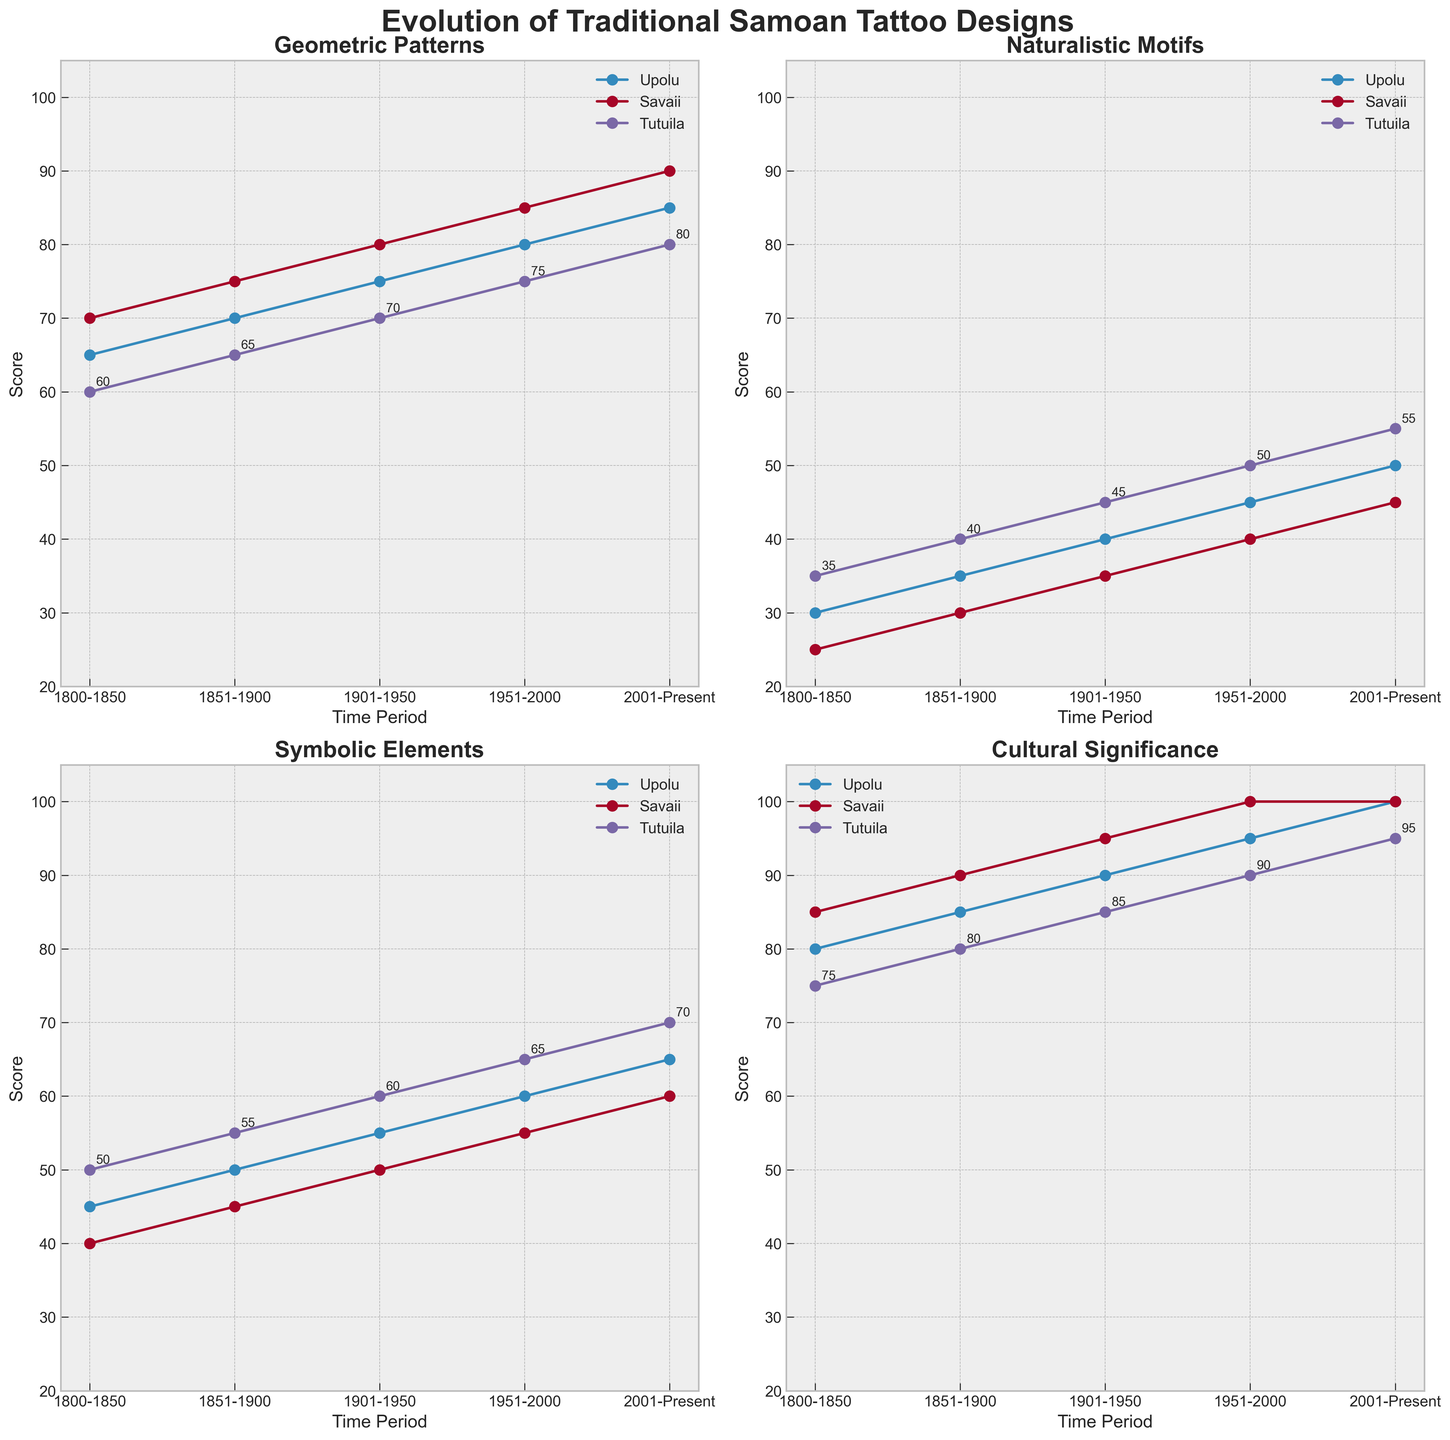Which region has the highest score for Geometric Patterns in the period 2001-Present? By looking at the "Geometric Patterns" subplot and noting the highest points for the period 2001-Present, it can be seen that Savaii has the highest score.
Answer: Savaii Which region shows the greatest increase in Cultural Significance from 1800-1850 to 2001-Present? To find this, assess the Cultural Significance subplot by subtracting the scores from 1800-1850 to 2001-Present for each region. Upolu shows an increase from 80 to 100 (20 points), Savaii from 85 to 100 (15 points), and Tutuila from 75 to 95 (20 points). Both Upolu and Tutuila have the greatest increase of 20 points.
Answer: Upolu and Tutuila What is the sum of Naturalistic Motifs scores for Upolu across all time periods? Add the Naturalistic Motifs scores for Upolu from each time period: 30 + 35 + 40 + 45 + 50 = 200.
Answer: 200 In which time period did Tutuila see the greatest increase in Symbolic Elements compared to the previous period? Track the changes for Tutuila in Symbolic Elements: 50 in 1800-1850 to 55 in 1851-1900 (a 5-point increase), 55 in 1851-1900 to 60 in 1901-1950 (another 5-point increase), 60 in 1901-1950 to 65 in 1951-2000 (also 5 points), and then 65 in 1951-2000 to 70 in 2001-Present (5 points). All increases are equal, hence the question is misleading.
Answer: Not applicable Which aspect shows the most stable (least variable) trend across all regions and time periods? To answer this, visually inspect the subplots for Geometric Patterns, Naturalistic Motifs, Symbolic Elements, and Cultural Significance to determine which has the least variation in trend lines. Naturalistic Motifs show consistent and less variable lines compared to other aspects.
Answer: Naturalistic Motifs Which region had the highest score for Symbolic Elements in the period 1951-2000? Examine the Symbolic Elements subplot and locate the highest score in 1951-2000, which is 65 for Tutuila.
Answer: Tutuila For the time period of 1901-1950, which aspect had the highest average score across all regions? Calculate the average for each aspect in the period 1901-1950. Geometric Patterns: (75+80+70)/3 = 75; Naturalistic Motifs: (40+35+45)/3 ≈ 40; Symbolic Elements: (55+50+60)/3 ≈ 55; Cultural Significance: (90+95+85)/3 ≈ 90. Therefore, Cultural Significance had the highest average score.
Answer: Cultural Significance 